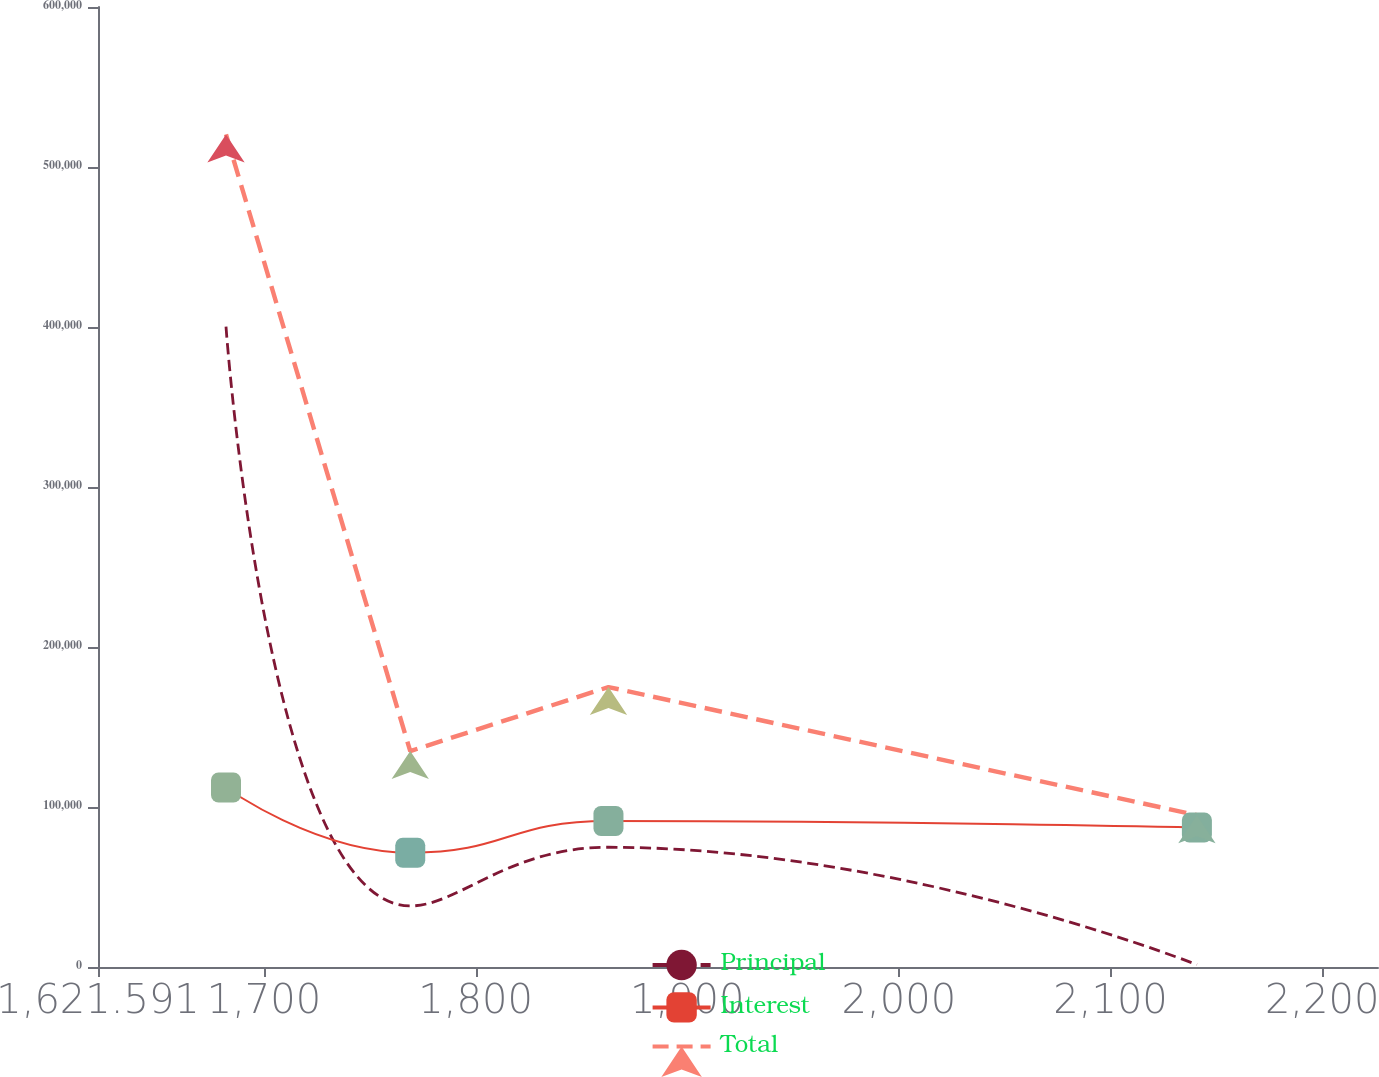Convert chart. <chart><loc_0><loc_0><loc_500><loc_500><line_chart><ecel><fcel>Principal<fcel>Interest<fcel>Total<nl><fcel>1682.07<fcel>400168<fcel>112153<fcel>520340<nl><fcel>1769.12<fcel>38145.9<fcel>71437.7<fcel>134925<nl><fcel>1862.78<fcel>74848.9<fcel>91270.2<fcel>174978<nl><fcel>2140.81<fcel>1442.78<fcel>87198.7<fcel>94871.5<nl><fcel>2286.86<fcel>363465<fcel>79147.4<fcel>480287<nl></chart> 